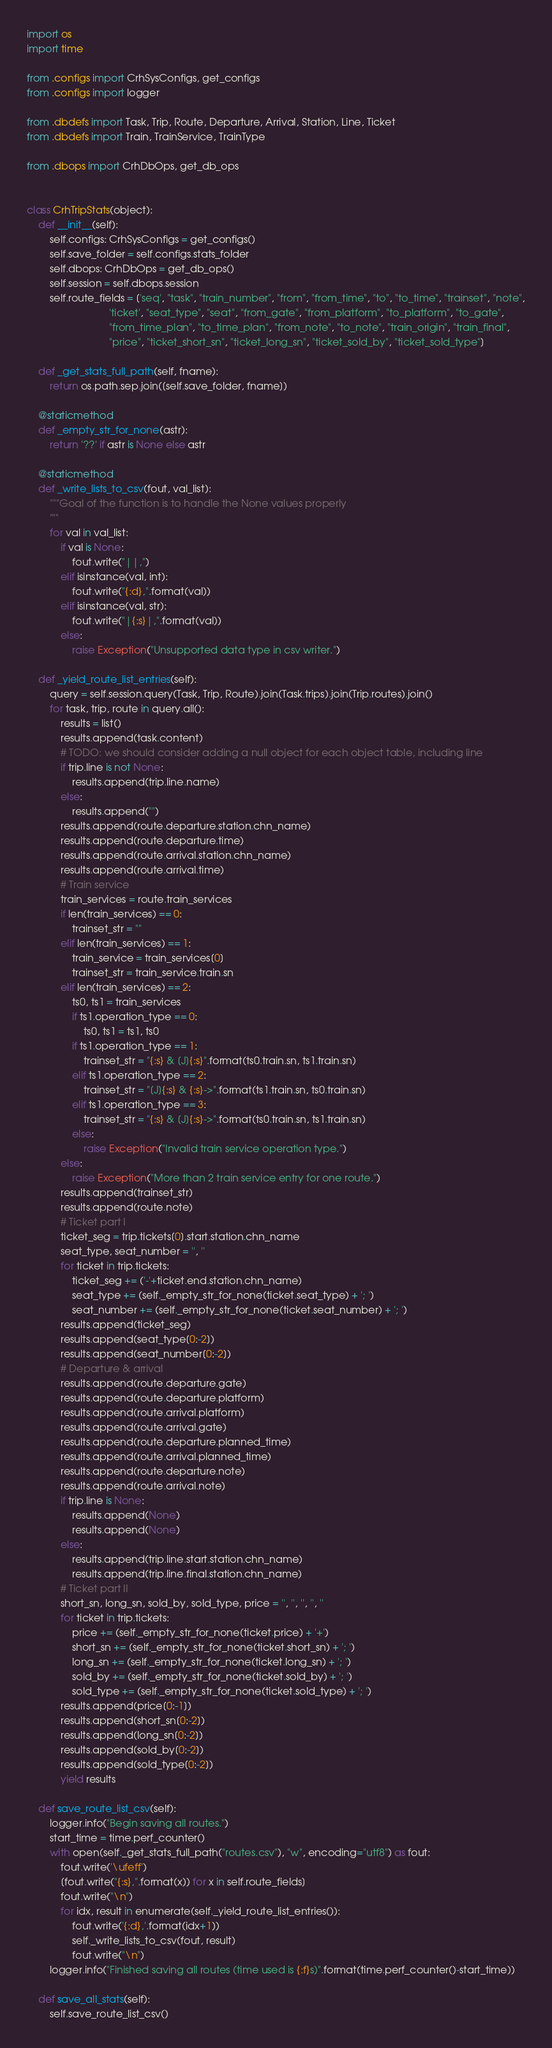<code> <loc_0><loc_0><loc_500><loc_500><_Python_>import os
import time

from .configs import CrhSysConfigs, get_configs
from .configs import logger

from .dbdefs import Task, Trip, Route, Departure, Arrival, Station, Line, Ticket
from .dbdefs import Train, TrainService, TrainType

from .dbops import CrhDbOps, get_db_ops


class CrhTripStats(object):
    def __init__(self):
        self.configs: CrhSysConfigs = get_configs()
        self.save_folder = self.configs.stats_folder
        self.dbops: CrhDbOps = get_db_ops()
        self.session = self.dbops.session
        self.route_fields = ['seq', "task", "train_number", "from", "from_time", "to", "to_time", "trainset", "note",
                             'ticket', "seat_type", "seat", "from_gate", "from_platform", "to_platform", "to_gate",
                             "from_time_plan", "to_time_plan", "from_note", "to_note", "train_origin", "train_final",
                             "price", "ticket_short_sn", "ticket_long_sn", "ticket_sold_by", "ticket_sold_type"]

    def _get_stats_full_path(self, fname):
        return os.path.sep.join([self.save_folder, fname])

    @staticmethod
    def _empty_str_for_none(astr):
        return '??' if astr is None else astr

    @staticmethod
    def _write_lists_to_csv(fout, val_list):
        """Goal of the function is to handle the None values properly
        """
        for val in val_list:
            if val is None:
                fout.write("||,")
            elif isinstance(val, int):
                fout.write("{:d},".format(val))
            elif isinstance(val, str):
                fout.write("|{:s}|,".format(val))
            else:
                raise Exception("Unsupported data type in csv writer.")

    def _yield_route_list_entries(self):
        query = self.session.query(Task, Trip, Route).join(Task.trips).join(Trip.routes).join()
        for task, trip, route in query.all():
            results = list()
            results.append(task.content)
            # TODO: we should consider adding a null object for each object table, including line
            if trip.line is not None:
                results.append(trip.line.name)
            else:
                results.append("")
            results.append(route.departure.station.chn_name)
            results.append(route.departure.time)
            results.append(route.arrival.station.chn_name)
            results.append(route.arrival.time)
            # Train service
            train_services = route.train_services
            if len(train_services) == 0:
                trainset_str = ""
            elif len(train_services) == 1:
                train_service = train_services[0]
                trainset_str = train_service.train.sn
            elif len(train_services) == 2:
                ts0, ts1 = train_services
                if ts1.operation_type == 0:
                    ts0, ts1 = ts1, ts0
                if ts1.operation_type == 1:
                    trainset_str = "{:s} & [J]{:s}".format(ts0.train.sn, ts1.train.sn)
                elif ts1.operation_type == 2:
                    trainset_str = "[J]{:s} & {:s}->".format(ts1.train.sn, ts0.train.sn)
                elif ts1.operation_type == 3:
                    trainset_str = "{:s} & [J]{:s}->".format(ts0.train.sn, ts1.train.sn)
                else:
                    raise Exception("Invalid train service operation type.")
            else:
                raise Exception("More than 2 train service entry for one route.")
            results.append(trainset_str)
            results.append(route.note)
            # Ticket part I
            ticket_seg = trip.tickets[0].start.station.chn_name
            seat_type, seat_number = '', ''
            for ticket in trip.tickets:
                ticket_seg += ('-'+ticket.end.station.chn_name)
                seat_type += (self._empty_str_for_none(ticket.seat_type) + '; ')
                seat_number += (self._empty_str_for_none(ticket.seat_number) + '; ')
            results.append(ticket_seg)
            results.append(seat_type[0:-2])
            results.append(seat_number[0:-2])
            # Departure & arrival
            results.append(route.departure.gate)
            results.append(route.departure.platform)
            results.append(route.arrival.platform)
            results.append(route.arrival.gate)
            results.append(route.departure.planned_time)
            results.append(route.arrival.planned_time)
            results.append(route.departure.note)
            results.append(route.arrival.note)
            if trip.line is None:
                results.append(None)
                results.append(None)
            else:
                results.append(trip.line.start.station.chn_name)
                results.append(trip.line.final.station.chn_name)
            # Ticket part II
            short_sn, long_sn, sold_by, sold_type, price = '', '', '', '', ''
            for ticket in trip.tickets:
                price += (self._empty_str_for_none(ticket.price) + '+')
                short_sn += (self._empty_str_for_none(ticket.short_sn) + '; ')
                long_sn += (self._empty_str_for_none(ticket.long_sn) + '; ')
                sold_by += (self._empty_str_for_none(ticket.sold_by) + '; ')
                sold_type += (self._empty_str_for_none(ticket.sold_type) + '; ')
            results.append(price[0:-1])
            results.append(short_sn[0:-2])
            results.append(long_sn[0:-2])
            results.append(sold_by[0:-2])
            results.append(sold_type[0:-2])
            yield results

    def save_route_list_csv(self):
        logger.info("Begin saving all routes.")
        start_time = time.perf_counter()
        with open(self._get_stats_full_path("routes.csv"), "w", encoding="utf8") as fout:
            fout.write('\ufeff')
            [fout.write("{:s},".format(x)) for x in self.route_fields]
            fout.write("\n")
            for idx, result in enumerate(self._yield_route_list_entries()):
                fout.write('{:d},'.format(idx+1))
                self._write_lists_to_csv(fout, result)
                fout.write("\n")
        logger.info("Finished saving all routes (time used is {:f}s)".format(time.perf_counter()-start_time))

    def save_all_stats(self):
        self.save_route_list_csv()
</code> 